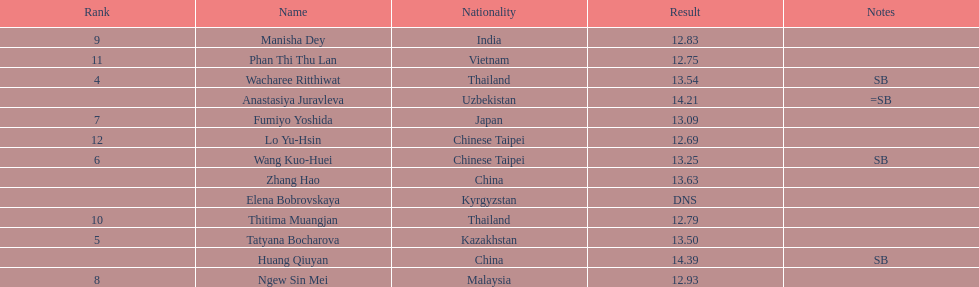What nationality was the woman who won first place? China. 